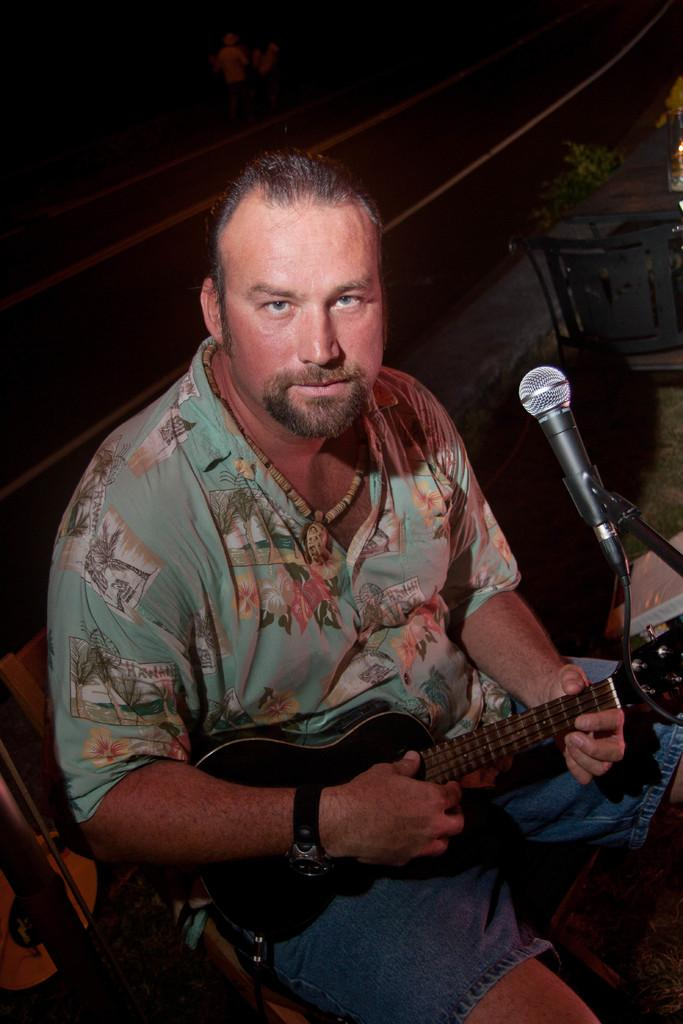What is the color of the background in the image? The background of the image is dark. What type of furniture can be seen in the image? There is a table and a chair in the image. Who is sitting on the chair in the image? A man is sitting on the chair in the image. What is the man doing in the image? The man is playing a guitar in the image. What is the man positioned in front of in the image? The man is in front of a microphone in the image. What type of bead is the man wearing around his neck in the image? There is no bead visible around the man's neck in the image. How many rings is the man wearing on his fingers in the image? There is no mention of rings in the image; the man is only shown playing a guitar and sitting in front of a microphone. 